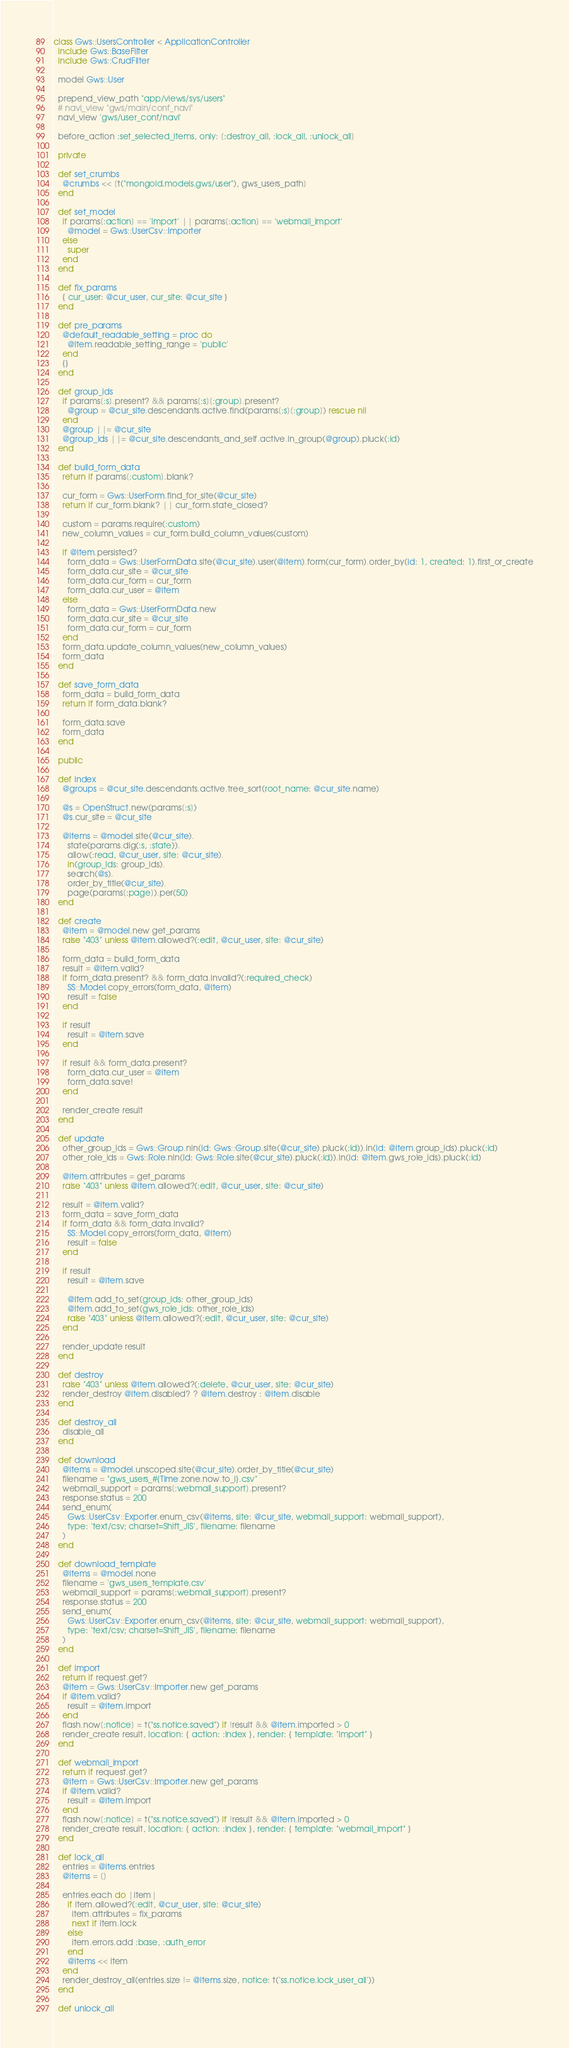Convert code to text. <code><loc_0><loc_0><loc_500><loc_500><_Ruby_>class Gws::UsersController < ApplicationController
  include Gws::BaseFilter
  include Gws::CrudFilter

  model Gws::User

  prepend_view_path "app/views/sys/users"
  # navi_view "gws/main/conf_navi"
  navi_view 'gws/user_conf/navi'

  before_action :set_selected_items, only: [:destroy_all, :lock_all, :unlock_all]

  private

  def set_crumbs
    @crumbs << [t("mongoid.models.gws/user"), gws_users_path]
  end

  def set_model
    if params[:action] == 'import' || params[:action] == 'webmail_import'
      @model = Gws::UserCsv::Importer
    else
      super
    end
  end

  def fix_params
    { cur_user: @cur_user, cur_site: @cur_site }
  end

  def pre_params
    @default_readable_setting = proc do
      @item.readable_setting_range = 'public'
    end
    {}
  end

  def group_ids
    if params[:s].present? && params[:s][:group].present?
      @group = @cur_site.descendants.active.find(params[:s][:group]) rescue nil
    end
    @group ||= @cur_site
    @group_ids ||= @cur_site.descendants_and_self.active.in_group(@group).pluck(:id)
  end

  def build_form_data
    return if params[:custom].blank?

    cur_form = Gws::UserForm.find_for_site(@cur_site)
    return if cur_form.blank? || cur_form.state_closed?

    custom = params.require(:custom)
    new_column_values = cur_form.build_column_values(custom)

    if @item.persisted?
      form_data = Gws::UserFormData.site(@cur_site).user(@item).form(cur_form).order_by(id: 1, created: 1).first_or_create
      form_data.cur_site = @cur_site
      form_data.cur_form = cur_form
      form_data.cur_user = @item
    else
      form_data = Gws::UserFormData.new
      form_data.cur_site = @cur_site
      form_data.cur_form = cur_form
    end
    form_data.update_column_values(new_column_values)
    form_data
  end

  def save_form_data
    form_data = build_form_data
    return if form_data.blank?

    form_data.save
    form_data
  end

  public

  def index
    @groups = @cur_site.descendants.active.tree_sort(root_name: @cur_site.name)

    @s = OpenStruct.new(params[:s])
    @s.cur_site = @cur_site

    @items = @model.site(@cur_site).
      state(params.dig(:s, :state)).
      allow(:read, @cur_user, site: @cur_site).
      in(group_ids: group_ids).
      search(@s).
      order_by_title(@cur_site).
      page(params[:page]).per(50)
  end

  def create
    @item = @model.new get_params
    raise "403" unless @item.allowed?(:edit, @cur_user, site: @cur_site)

    form_data = build_form_data
    result = @item.valid?
    if form_data.present? && form_data.invalid?(:required_check)
      SS::Model.copy_errors(form_data, @item)
      result = false
    end

    if result
      result = @item.save
    end

    if result && form_data.present?
      form_data.cur_user = @item
      form_data.save!
    end

    render_create result
  end

  def update
    other_group_ids = Gws::Group.nin(id: Gws::Group.site(@cur_site).pluck(:id)).in(id: @item.group_ids).pluck(:id)
    other_role_ids = Gws::Role.nin(id: Gws::Role.site(@cur_site).pluck(:id)).in(id: @item.gws_role_ids).pluck(:id)

    @item.attributes = get_params
    raise "403" unless @item.allowed?(:edit, @cur_user, site: @cur_site)

    result = @item.valid?
    form_data = save_form_data
    if form_data && form_data.invalid?
      SS::Model.copy_errors(form_data, @item)
      result = false
    end

    if result
      result = @item.save

      @item.add_to_set(group_ids: other_group_ids)
      @item.add_to_set(gws_role_ids: other_role_ids)
      raise "403" unless @item.allowed?(:edit, @cur_user, site: @cur_site)
    end

    render_update result
  end

  def destroy
    raise "403" unless @item.allowed?(:delete, @cur_user, site: @cur_site)
    render_destroy @item.disabled? ? @item.destroy : @item.disable
  end

  def destroy_all
    disable_all
  end

  def download
    @items = @model.unscoped.site(@cur_site).order_by_title(@cur_site)
    filename = "gws_users_#{Time.zone.now.to_i}.csv"
    webmail_support = params[:webmail_support].present?
    response.status = 200
    send_enum(
      Gws::UserCsv::Exporter.enum_csv(@items, site: @cur_site, webmail_support: webmail_support),
      type: 'text/csv; charset=Shift_JIS', filename: filename
    )
  end

  def download_template
    @items = @model.none
    filename = 'gws_users_template.csv'
    webmail_support = params[:webmail_support].present?
    response.status = 200
    send_enum(
      Gws::UserCsv::Exporter.enum_csv(@items, site: @cur_site, webmail_support: webmail_support),
      type: 'text/csv; charset=Shift_JIS', filename: filename
    )
  end

  def import
    return if request.get?
    @item = Gws::UserCsv::Importer.new get_params
    if @item.valid?
      result = @item.import
    end
    flash.now[:notice] = t("ss.notice.saved") if !result && @item.imported > 0
    render_create result, location: { action: :index }, render: { template: "import" }
  end

  def webmail_import
    return if request.get?
    @item = Gws::UserCsv::Importer.new get_params
    if @item.valid?
      result = @item.import
    end
    flash.now[:notice] = t("ss.notice.saved") if !result && @item.imported > 0
    render_create result, location: { action: :index }, render: { template: "webmail_import" }
  end

  def lock_all
    entries = @items.entries
    @items = []

    entries.each do |item|
      if item.allowed?(:edit, @cur_user, site: @cur_site)
        item.attributes = fix_params
        next if item.lock
      else
        item.errors.add :base, :auth_error
      end
      @items << item
    end
    render_destroy_all(entries.size != @items.size, notice: t('ss.notice.lock_user_all'))
  end

  def unlock_all</code> 